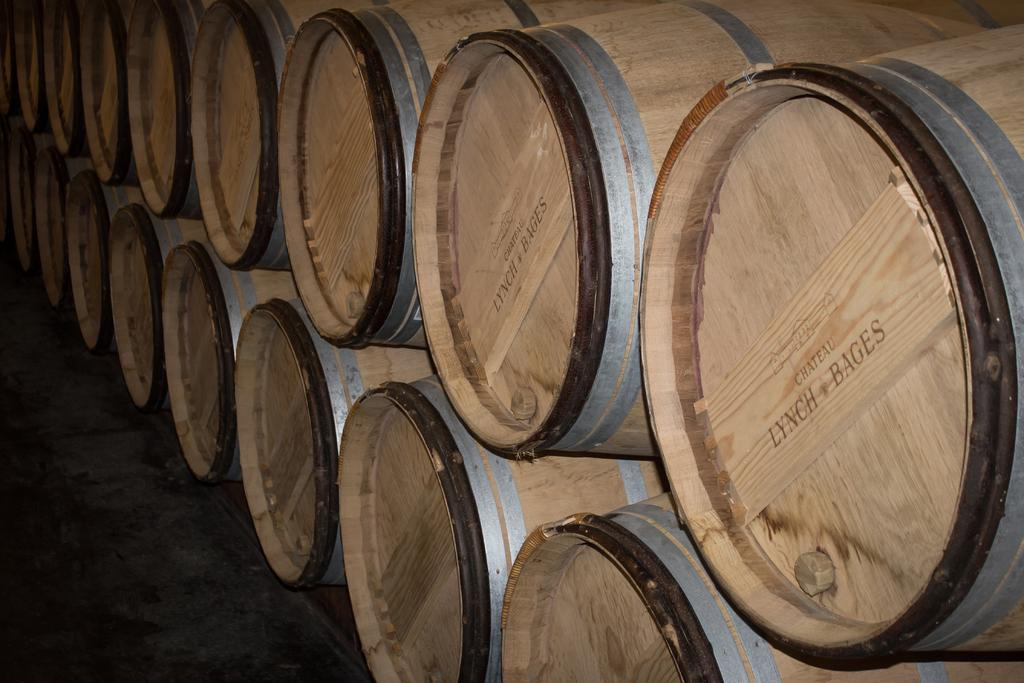What objects are present on the surface in the image? There are barrels on the surface in the image. What type of eggnog is being stored in the barrels in the image? There is no indication of eggnog or any other liquid being stored in the barrels in the image. 